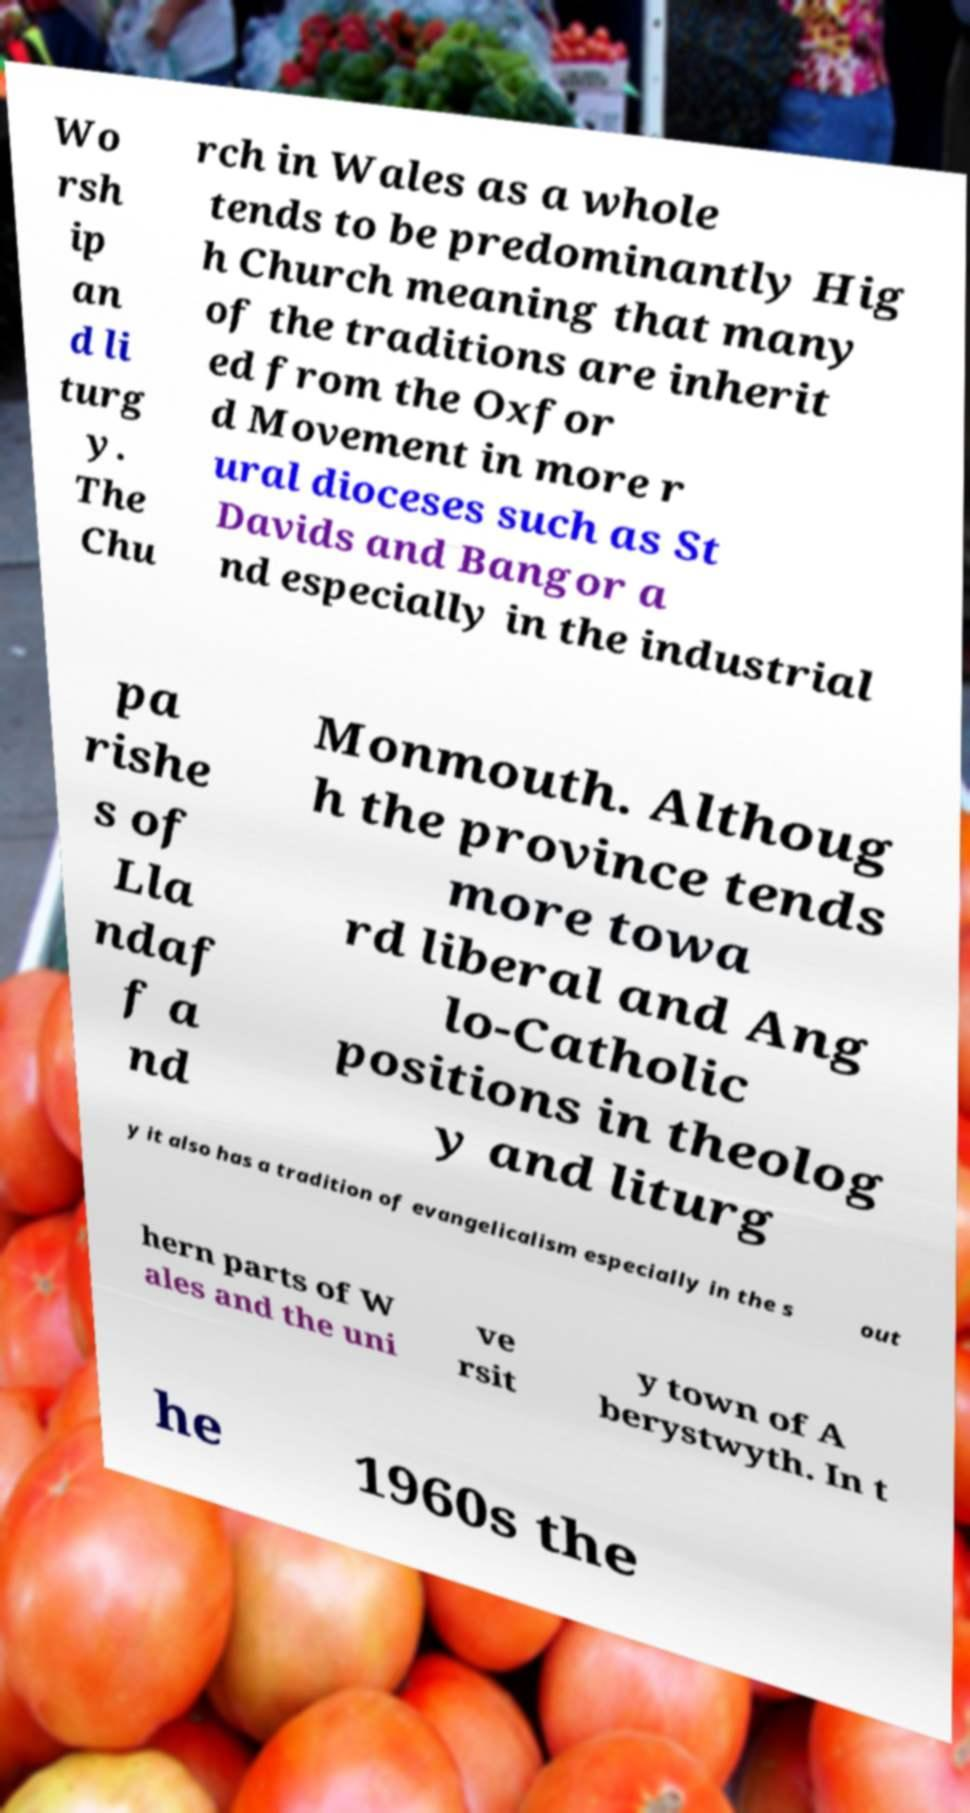Could you assist in decoding the text presented in this image and type it out clearly? Wo rsh ip an d li turg y. The Chu rch in Wales as a whole tends to be predominantly Hig h Church meaning that many of the traditions are inherit ed from the Oxfor d Movement in more r ural dioceses such as St Davids and Bangor a nd especially in the industrial pa rishe s of Lla ndaf f a nd Monmouth. Althoug h the province tends more towa rd liberal and Ang lo-Catholic positions in theolog y and liturg y it also has a tradition of evangelicalism especially in the s out hern parts of W ales and the uni ve rsit y town of A berystwyth. In t he 1960s the 